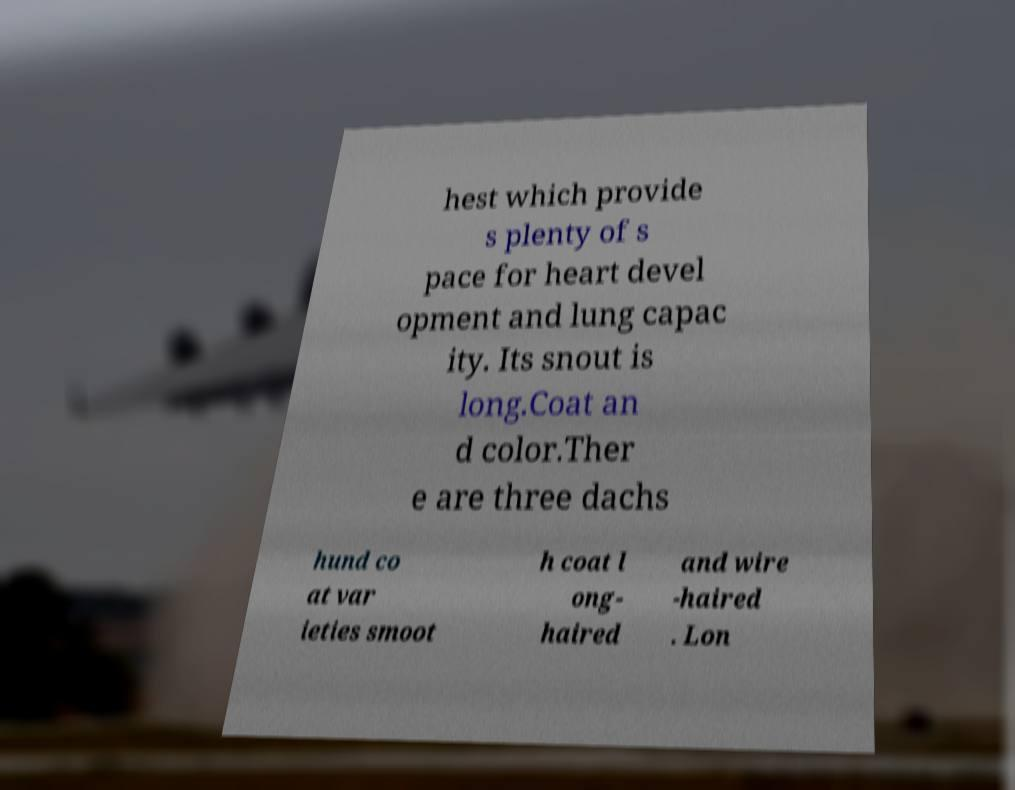Please read and relay the text visible in this image. What does it say? hest which provide s plenty of s pace for heart devel opment and lung capac ity. Its snout is long.Coat an d color.Ther e are three dachs hund co at var ieties smoot h coat l ong- haired and wire -haired . Lon 